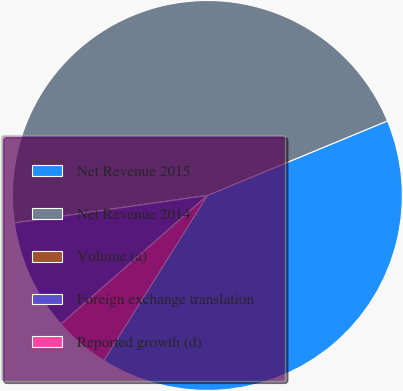<chart> <loc_0><loc_0><loc_500><loc_500><pie_chart><fcel>Net Revenue 2015<fcel>Net Revenue 2014<fcel>Volume (a)<fcel>Foreign exchange translation<fcel>Reported growth (d)<nl><fcel>40.17%<fcel>46.01%<fcel>0.0%<fcel>9.21%<fcel>4.61%<nl></chart> 